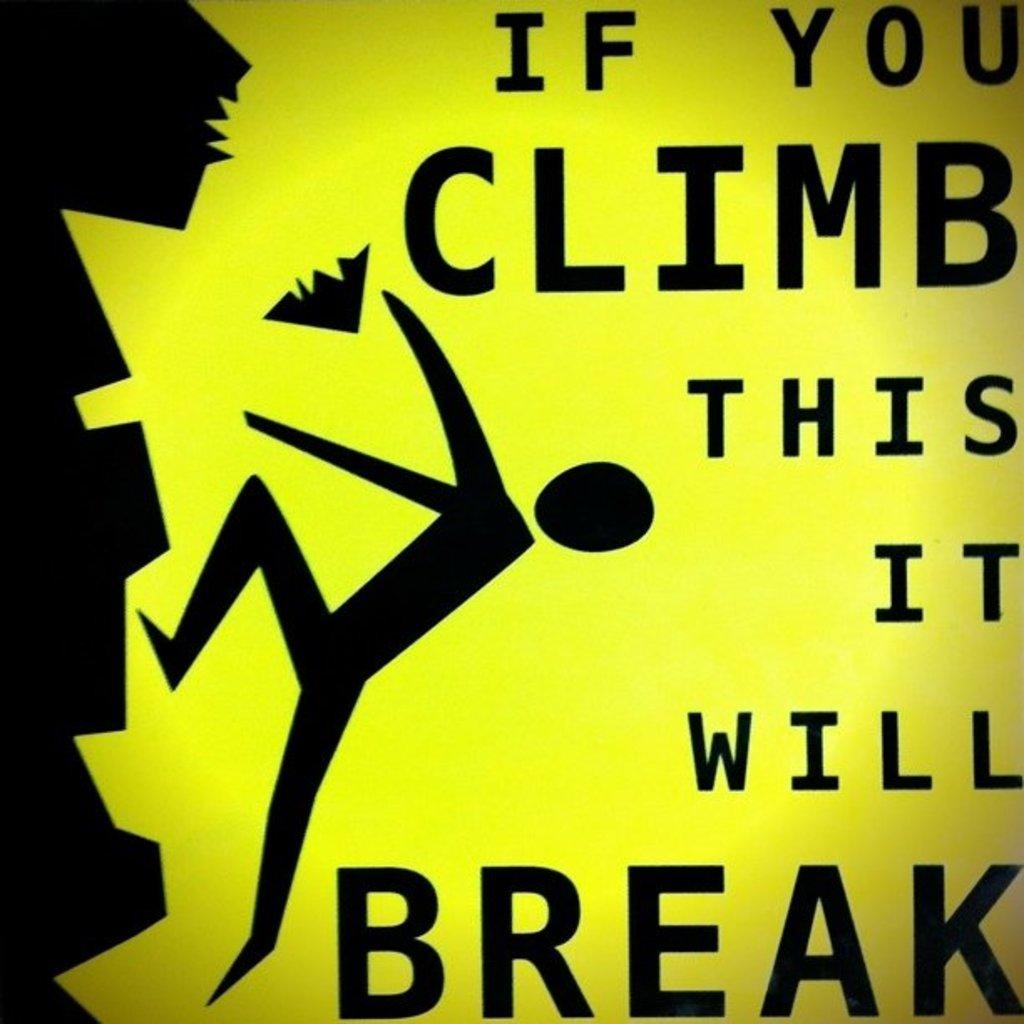When does it break?
Provide a short and direct response. If you climb. 